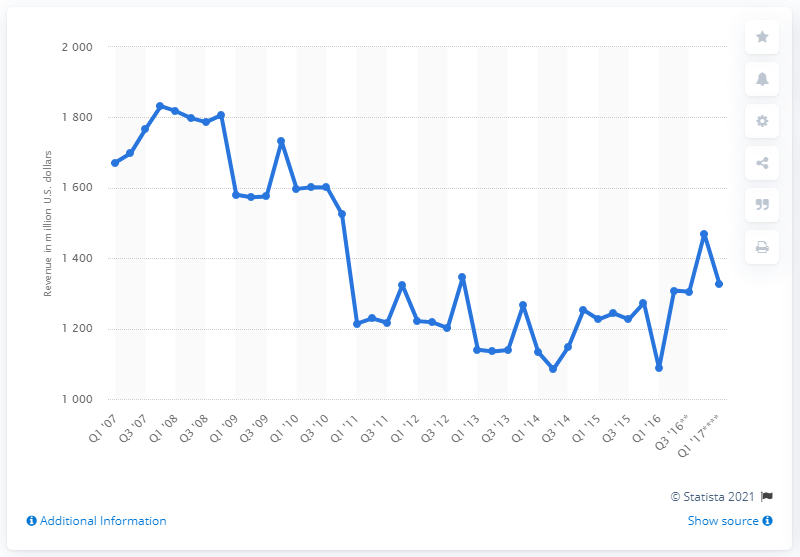List a handful of essential elements in this visual. Yahoo's GAAP revenue in the most recent quarter was $1,327. 